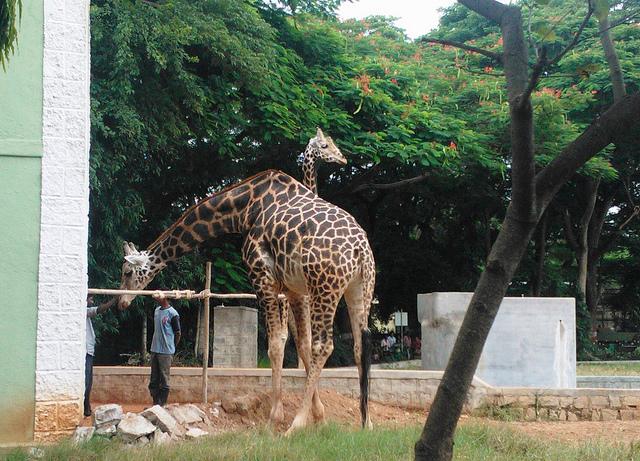What color are the giraffes?
Keep it brief. Brown. Are both the giraffes lying down?
Quick response, please. No. Is this in a park?
Short answer required. Yes. 